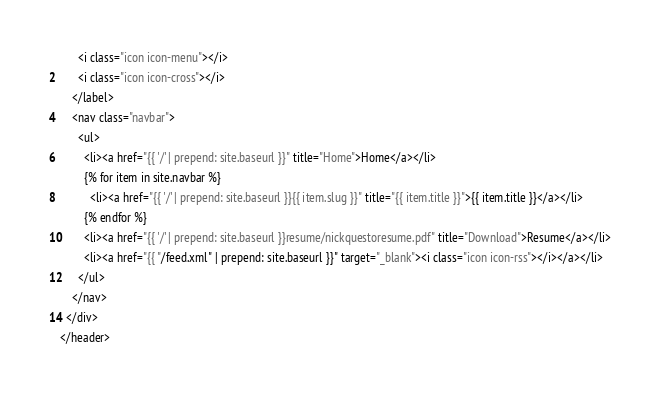Convert code to text. <code><loc_0><loc_0><loc_500><loc_500><_HTML_>      <i class="icon icon-menu"></i>
      <i class="icon icon-cross"></i>
    </label>
    <nav class="navbar">
      <ul>
        <li><a href="{{ '/' | prepend: site.baseurl }}" title="Home">Home</a></li>
        {% for item in site.navbar %}
          <li><a href="{{ '/' | prepend: site.baseurl }}{{ item.slug }}" title="{{ item.title }}">{{ item.title }}</a></li>
        {% endfor %}
        <li><a href="{{ '/' | prepend: site.baseurl }}resume/nickquestoresume.pdf" title="Download">Resume</a></li>
        <li><a href="{{ "/feed.xml" | prepend: site.baseurl }}" target="_blank"><i class="icon icon-rss"></i></a></li>
      </ul>
    </nav>
  </div>
</header>
</code> 